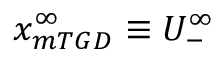Convert formula to latex. <formula><loc_0><loc_0><loc_500><loc_500>x _ { m T G D } ^ { \infty } \equiv U _ { - } ^ { \infty }</formula> 